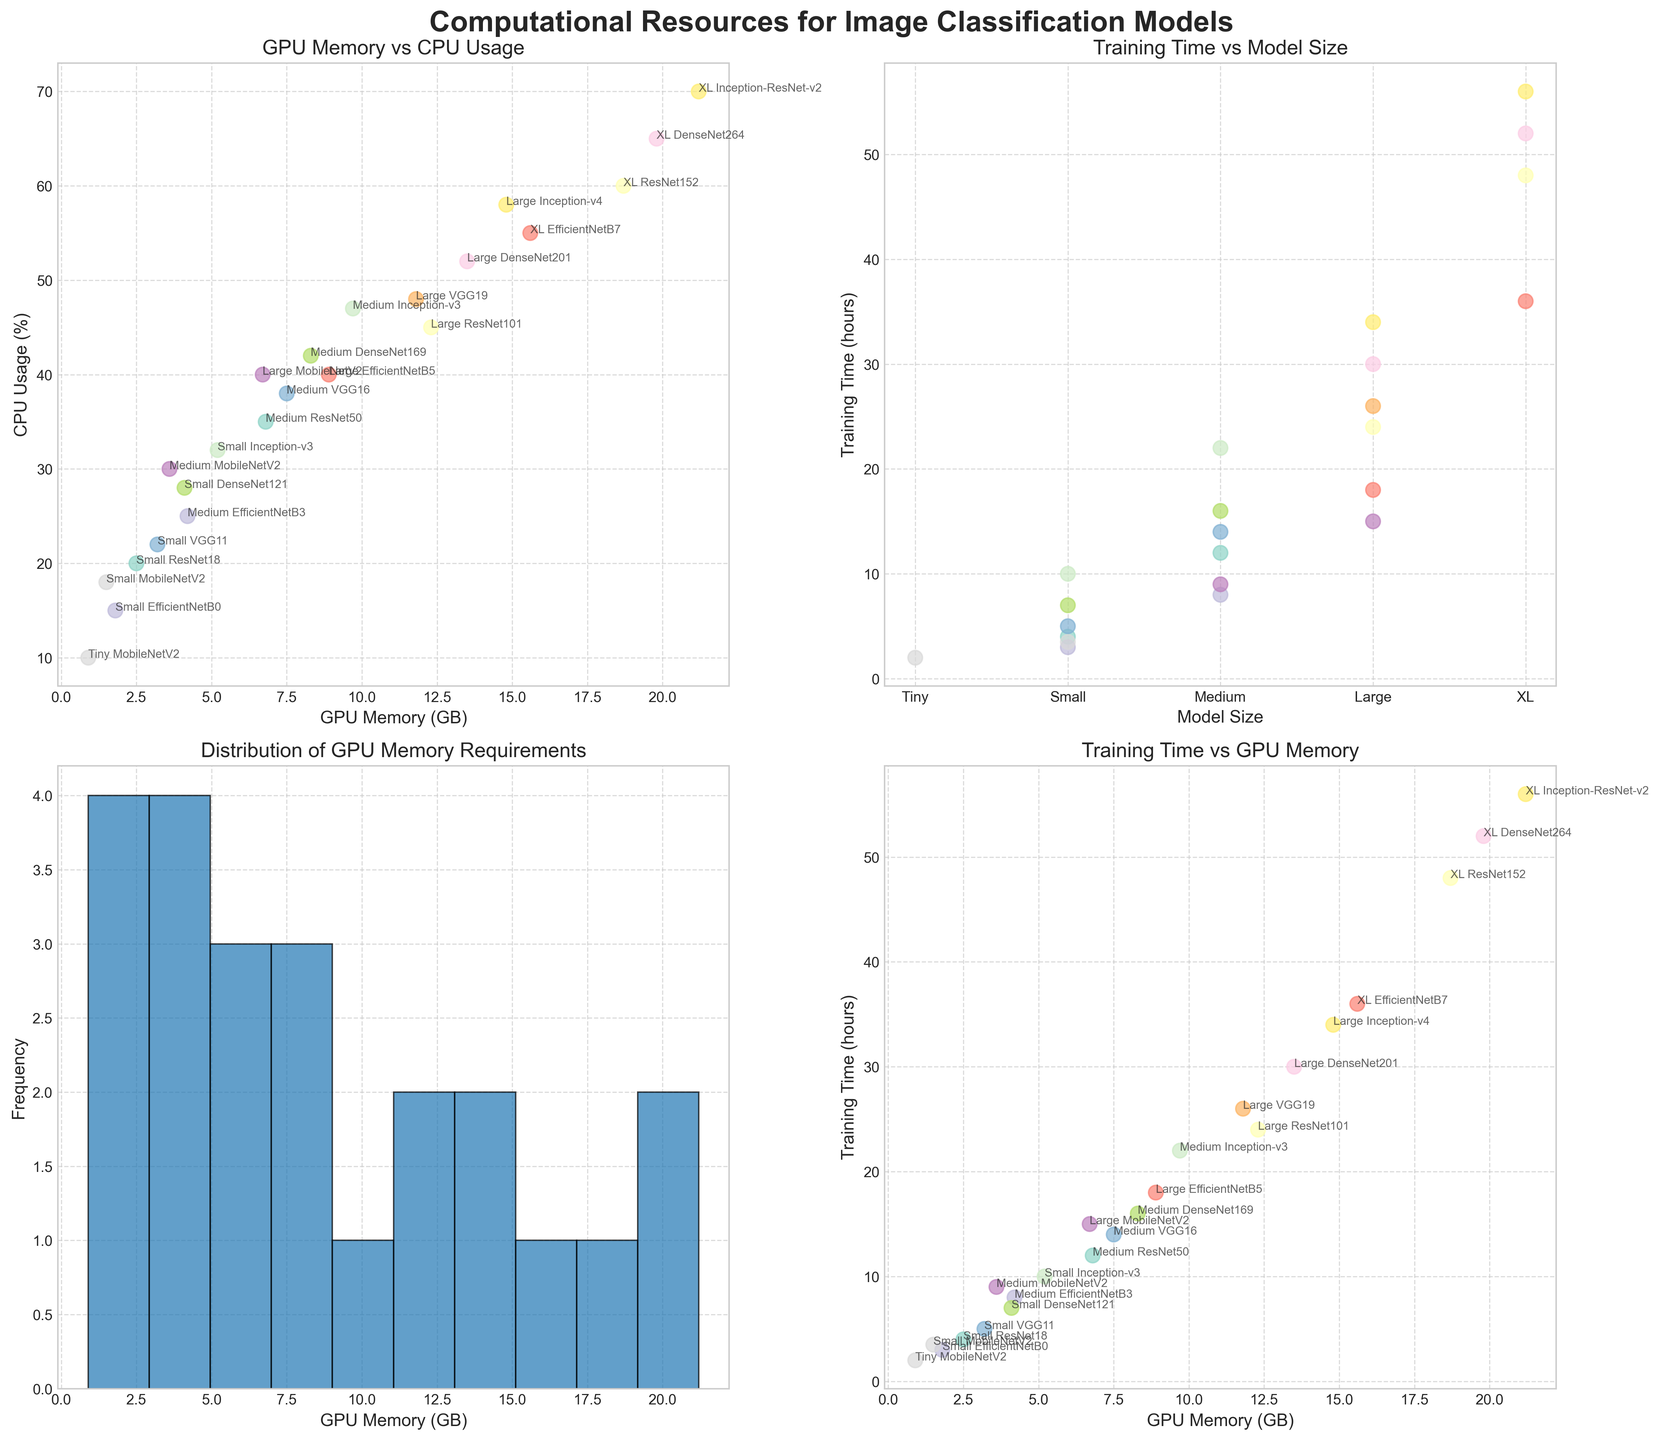How does the CPU usage correlate with GPU memory usage? To answer this, observe the scatter plot titled "GPU Memory vs CPU Usage". The general trend shows that as GPU memory usage increases, CPU usage also increases, indicating a positive correlation
Answer: Positively correlated Which model has the highest GPU memory usage, and how much is it? Look at the scatter plot "GPU Memory vs CPU Usage". The point with the highest GPU memory usage corresponds to the model "XL Inception-ResNet-v2", which uses 21.2 GB of GPU memory, as annotated in the plot
Answer: XL Inception-ResNet-v2, 21.2 GB What's the range of training times for 'Small' sized models? Check the plot "Training Time vs Model Size". Identify the points labeled as 'Small' (Small ResNet18, Small EfficientNetB0, Small VGG11, Small DenseNet121, Small MobileNetV2, Small Inception-v3). Note their training times and find the range. Training times are 4, 3, 5, 7, 3.5, and 10 hours respectively, giving a range of 3 to 10 hours
Answer: 3 to 10 hours Which model has the lowest CPU usage, and what is its value? In the plot "GPU Memory vs CPU Usage", find the point with the lowest CPU usage. The corresponding model is "Tiny MobileNetV2" with 10% CPU usage
Answer: Tiny MobileNetV2, 10% What is the median GPU memory requirement across all models? Observe the plot titled "Distribution of GPU Memory Requirements". To find the median, consider the middle value in the sorted list of GPU memory values. Visually, the plot shows a histogram with values scattered around 6.8 GB in the middle bin, suggesting the median is around this value
Answer: Approximately 6.8 GB How does training time vary with GPU memory usage? Refer to the plot "Training Time vs GPU Memory". The scatter plot shows that as GPU memory increases, training time also tends to increase, indicating a positive correlation
Answer: Positively correlated Which model(s) fall in the first quartile of GPU memory distribution? Look at the "Distribution of GPU Memory Requirements" histogram. The first quartile suggests the first quarter of the distribution. The models in the first quartile (approximately up to 4.1 GB) include Tiny MobileNetV2, Small EfficientNetB0, Small MobileNetV2, Small ResNet18, Small VGG11, and Small DenseNet121
Answer: Tiny MobileNetV2, Small EfficientNetB0, Small MobileNetV2, Small ResNet18, Small VGG11, Small DenseNet121 Are there any "Medium" models with GPU memory greater than 10 GB? Check the scatter plot "GPU Memory vs CPU Usage" for models labeled 'Medium'. None of the 'Medium' models exceed 10 GB of GPU memory usage
Answer: No What is the average training time of all models? Sum all training times and divide by the number of models. Summing the training times: (4+12+24+48+3+8+18+36+5+14+26+7+16+30+52+2+3.5+9+15+10+22+34+56) = 426. Dividing by 23 models gives 426/23 ≈ 18.52 hours
Answer: Approximately 18.52 hours Which model has the highest CPU usage and what is its training time? Look at the highest point on the scatter plot "GPU Memory vs CPU Usage". The model "XL Inception-ResNet-v2" has the highest CPU usage at 70%, with a training time of 56 hours. This is detailed in the annotations on the plot
Answer: XL Inception-ResNet-v2, 56 hours 